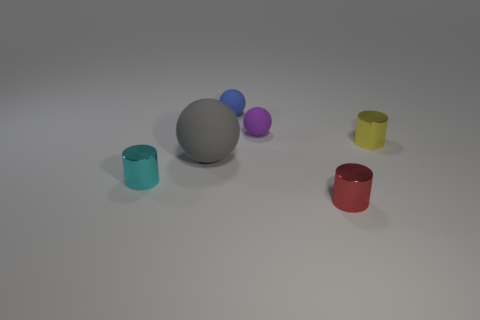Add 1 blue cylinders. How many objects exist? 7 Add 5 small cyan things. How many small cyan things exist? 6 Subtract 0 gray cubes. How many objects are left? 6 Subtract all large spheres. Subtract all metallic cylinders. How many objects are left? 2 Add 3 cyan metal objects. How many cyan metal objects are left? 4 